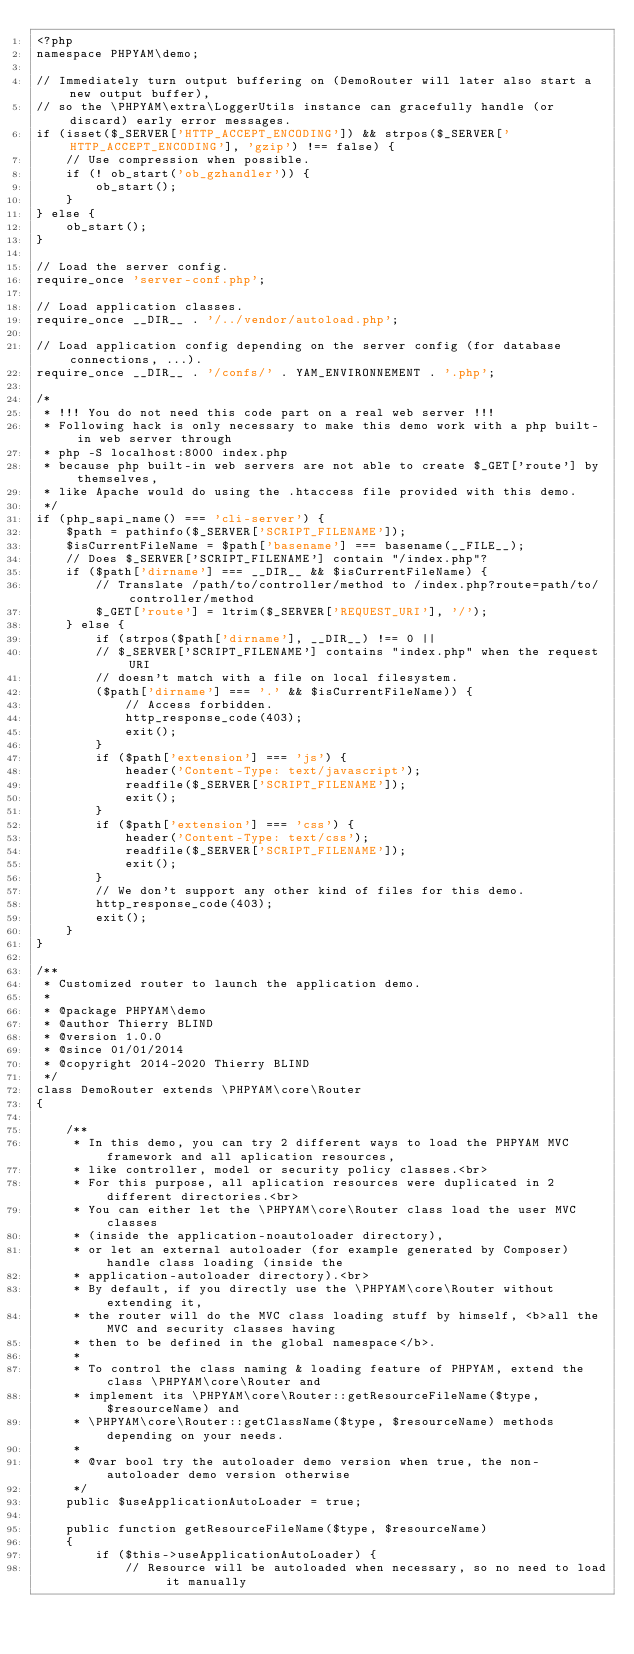Convert code to text. <code><loc_0><loc_0><loc_500><loc_500><_PHP_><?php
namespace PHPYAM\demo;

// Immediately turn output buffering on (DemoRouter will later also start a new output buffer),
// so the \PHPYAM\extra\LoggerUtils instance can gracefully handle (or discard) early error messages.
if (isset($_SERVER['HTTP_ACCEPT_ENCODING']) && strpos($_SERVER['HTTP_ACCEPT_ENCODING'], 'gzip') !== false) {
    // Use compression when possible.
    if (! ob_start('ob_gzhandler')) {
        ob_start();
    }
} else {
    ob_start();
}

// Load the server config.
require_once 'server-conf.php';

// Load application classes.
require_once __DIR__ . '/../vendor/autoload.php';

// Load application config depending on the server config (for database connections, ...).
require_once __DIR__ . '/confs/' . YAM_ENVIRONNEMENT . '.php';

/*
 * !!! You do not need this code part on a real web server !!!
 * Following hack is only necessary to make this demo work with a php built-in web server through
 * php -S localhost:8000 index.php
 * because php built-in web servers are not able to create $_GET['route'] by themselves,
 * like Apache would do using the .htaccess file provided with this demo.
 */
if (php_sapi_name() === 'cli-server') {
    $path = pathinfo($_SERVER['SCRIPT_FILENAME']);
    $isCurrentFileName = $path['basename'] === basename(__FILE__);
    // Does $_SERVER['SCRIPT_FILENAME'] contain "/index.php"?
    if ($path['dirname'] === __DIR__ && $isCurrentFileName) {
        // Translate /path/to/controller/method to /index.php?route=path/to/controller/method
        $_GET['route'] = ltrim($_SERVER['REQUEST_URI'], '/');
    } else {
        if (strpos($path['dirname'], __DIR__) !== 0 ||
        // $_SERVER['SCRIPT_FILENAME'] contains "index.php" when the request URI
        // doesn't match with a file on local filesystem.
        ($path['dirname'] === '.' && $isCurrentFileName)) {
            // Access forbidden.
            http_response_code(403);
            exit();
        }
        if ($path['extension'] === 'js') {
            header('Content-Type: text/javascript');
            readfile($_SERVER['SCRIPT_FILENAME']);
            exit();
        }
        if ($path['extension'] === 'css') {
            header('Content-Type: text/css');
            readfile($_SERVER['SCRIPT_FILENAME']);
            exit();
        }
        // We don't support any other kind of files for this demo.
        http_response_code(403);
        exit();
    }
}

/**
 * Customized router to launch the application demo.
 *
 * @package PHPYAM\demo
 * @author Thierry BLIND
 * @version 1.0.0
 * @since 01/01/2014
 * @copyright 2014-2020 Thierry BLIND
 */
class DemoRouter extends \PHPYAM\core\Router
{

    /**
     * In this demo, you can try 2 different ways to load the PHPYAM MVC framework and all aplication resources,
     * like controller, model or security policy classes.<br>
     * For this purpose, all aplication resources were duplicated in 2 different directories.<br>
     * You can either let the \PHPYAM\core\Router class load the user MVC classes
     * (inside the application-noautoloader directory),
     * or let an external autoloader (for example generated by Composer) handle class loading (inside the
     * application-autoloader directory).<br>
     * By default, if you directly use the \PHPYAM\core\Router without extending it,
     * the router will do the MVC class loading stuff by himself, <b>all the MVC and security classes having
     * then to be defined in the global namespace</b>.
     *
     * To control the class naming & loading feature of PHPYAM, extend the class \PHPYAM\core\Router and
     * implement its \PHPYAM\core\Router::getResourceFileName($type, $resourceName) and
     * \PHPYAM\core\Router::getClassName($type, $resourceName) methods depending on your needs.
     *
     * @var bool try the autoloader demo version when true, the non-autoloader demo version otherwise
     */
    public $useApplicationAutoLoader = true;

    public function getResourceFileName($type, $resourceName)
    {
        if ($this->useApplicationAutoLoader) {
            // Resource will be autoloaded when necessary, so no need to load it manually</code> 